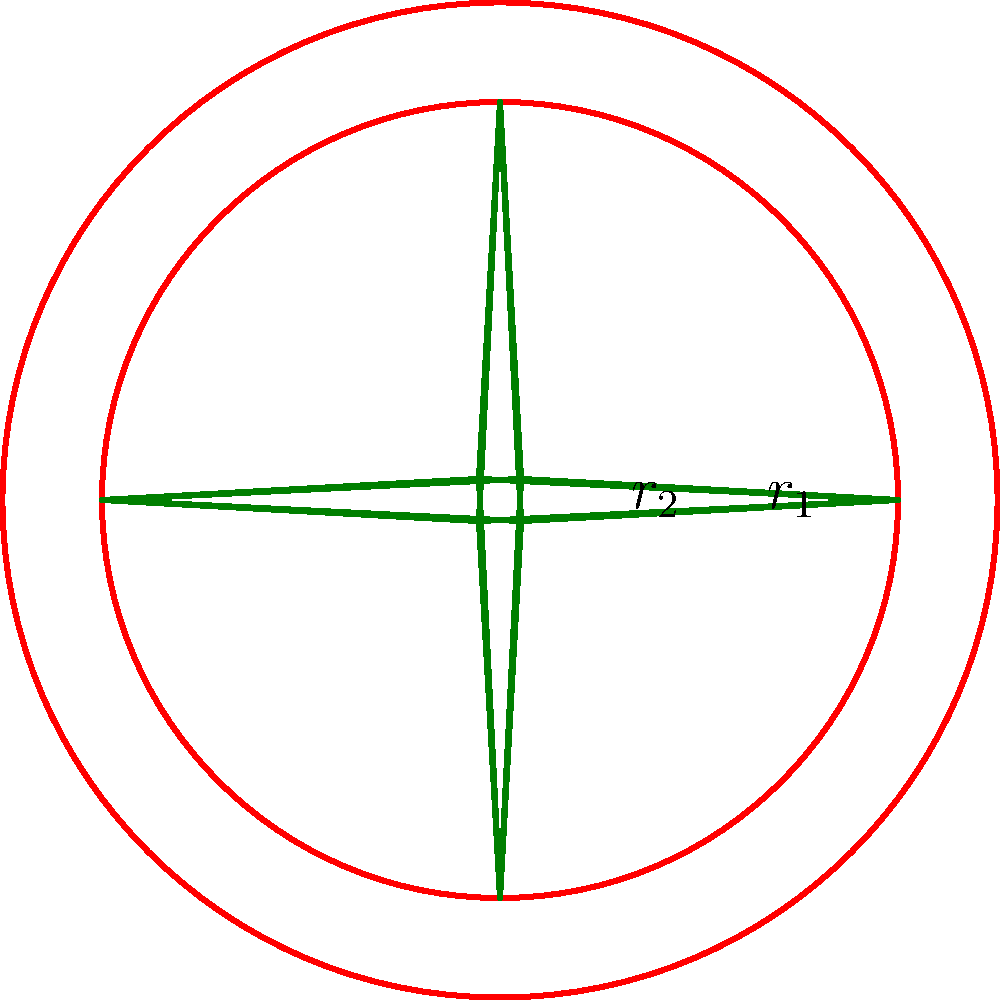As a filmmaker exploring Celtic art, you encounter a circular Celtic knot pattern. The knot is contained within two concentric circles, where the outer circle has a radius $r_1 = 5$ cm and the inner circle has a radius $r_2 = 4$ cm. The knot pattern touches both circles. Calculate the total perimeter of the visible parts of the knot pattern, assuming it consists of straight line segments between the points where it touches the circles. To solve this problem, let's break it down into steps:

1) First, we need to identify the shape of the knot. From the diagram, we can see that the knot forms a square-like shape with curved corners.

2) The knot touches the inner circle at four points, which form a square inscribed in the inner circle.

3) The side length of this inscribed square can be calculated using the formula for the diagonal of a square inscribed in a circle:
   $s = r_2 \sqrt{2}$, where $s$ is the side length and $r_2$ is the radius of the inner circle.

4) Substituting the given value: $s = 4 \sqrt{2}$ cm

5) The perimeter of the knot consists of 8 line segments (two for each side of the square-like shape).

6) The length of each of these segments is half the side length of the inscribed square:
   $\text{segment length} = \frac{s}{2} = \frac{4\sqrt{2}}{2} = 2\sqrt{2}$ cm

7) The total perimeter is the sum of all these segments:
   $\text{total perimeter} = 8 \times 2\sqrt{2} = 16\sqrt{2}$ cm

Therefore, the total perimeter of the visible parts of the knot pattern is $16\sqrt{2}$ cm.
Answer: $16\sqrt{2}$ cm 